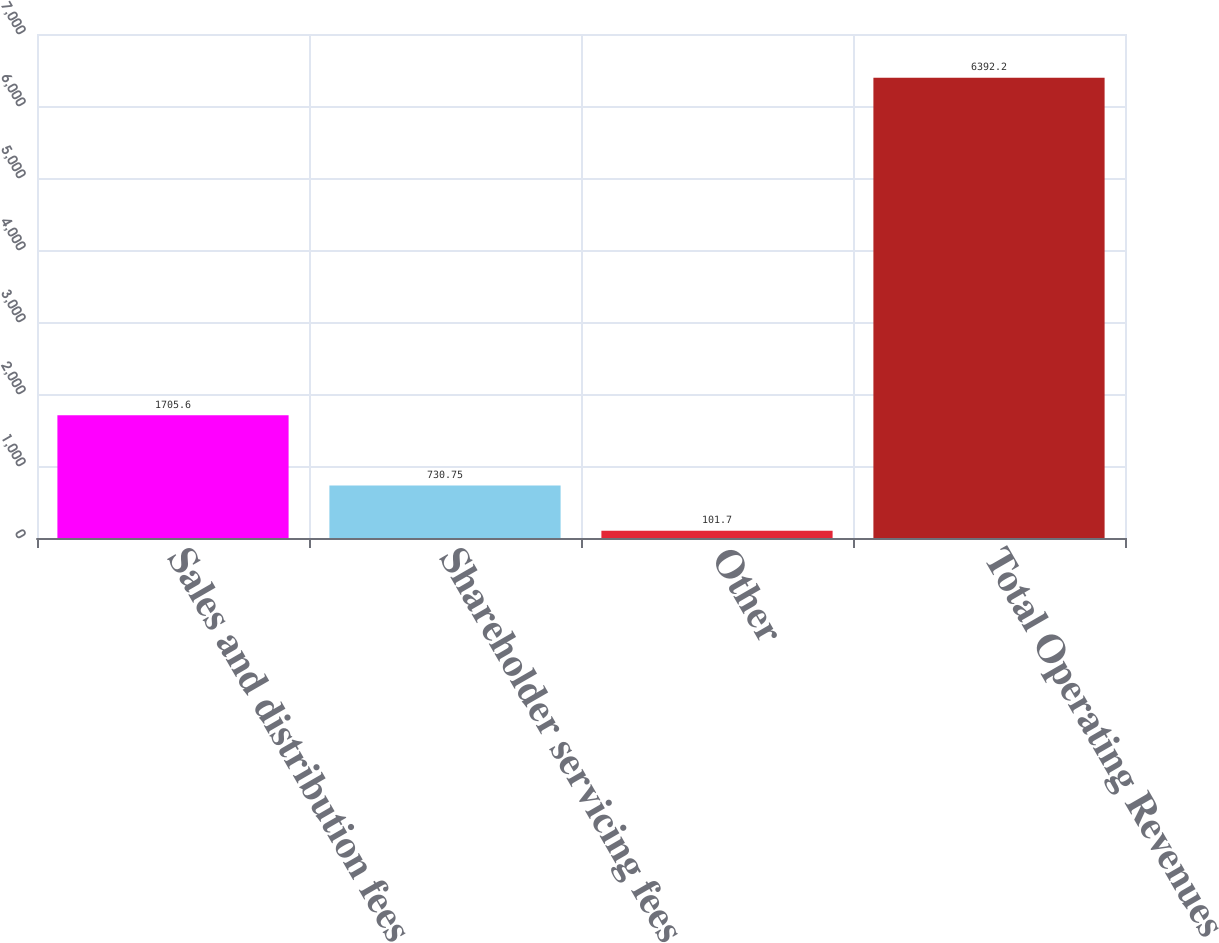Convert chart. <chart><loc_0><loc_0><loc_500><loc_500><bar_chart><fcel>Sales and distribution fees<fcel>Shareholder servicing fees<fcel>Other<fcel>Total Operating Revenues<nl><fcel>1705.6<fcel>730.75<fcel>101.7<fcel>6392.2<nl></chart> 